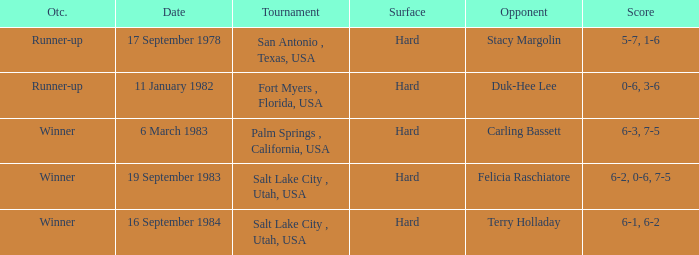What was the score of the match against duk-hee lee? 0-6, 3-6. 